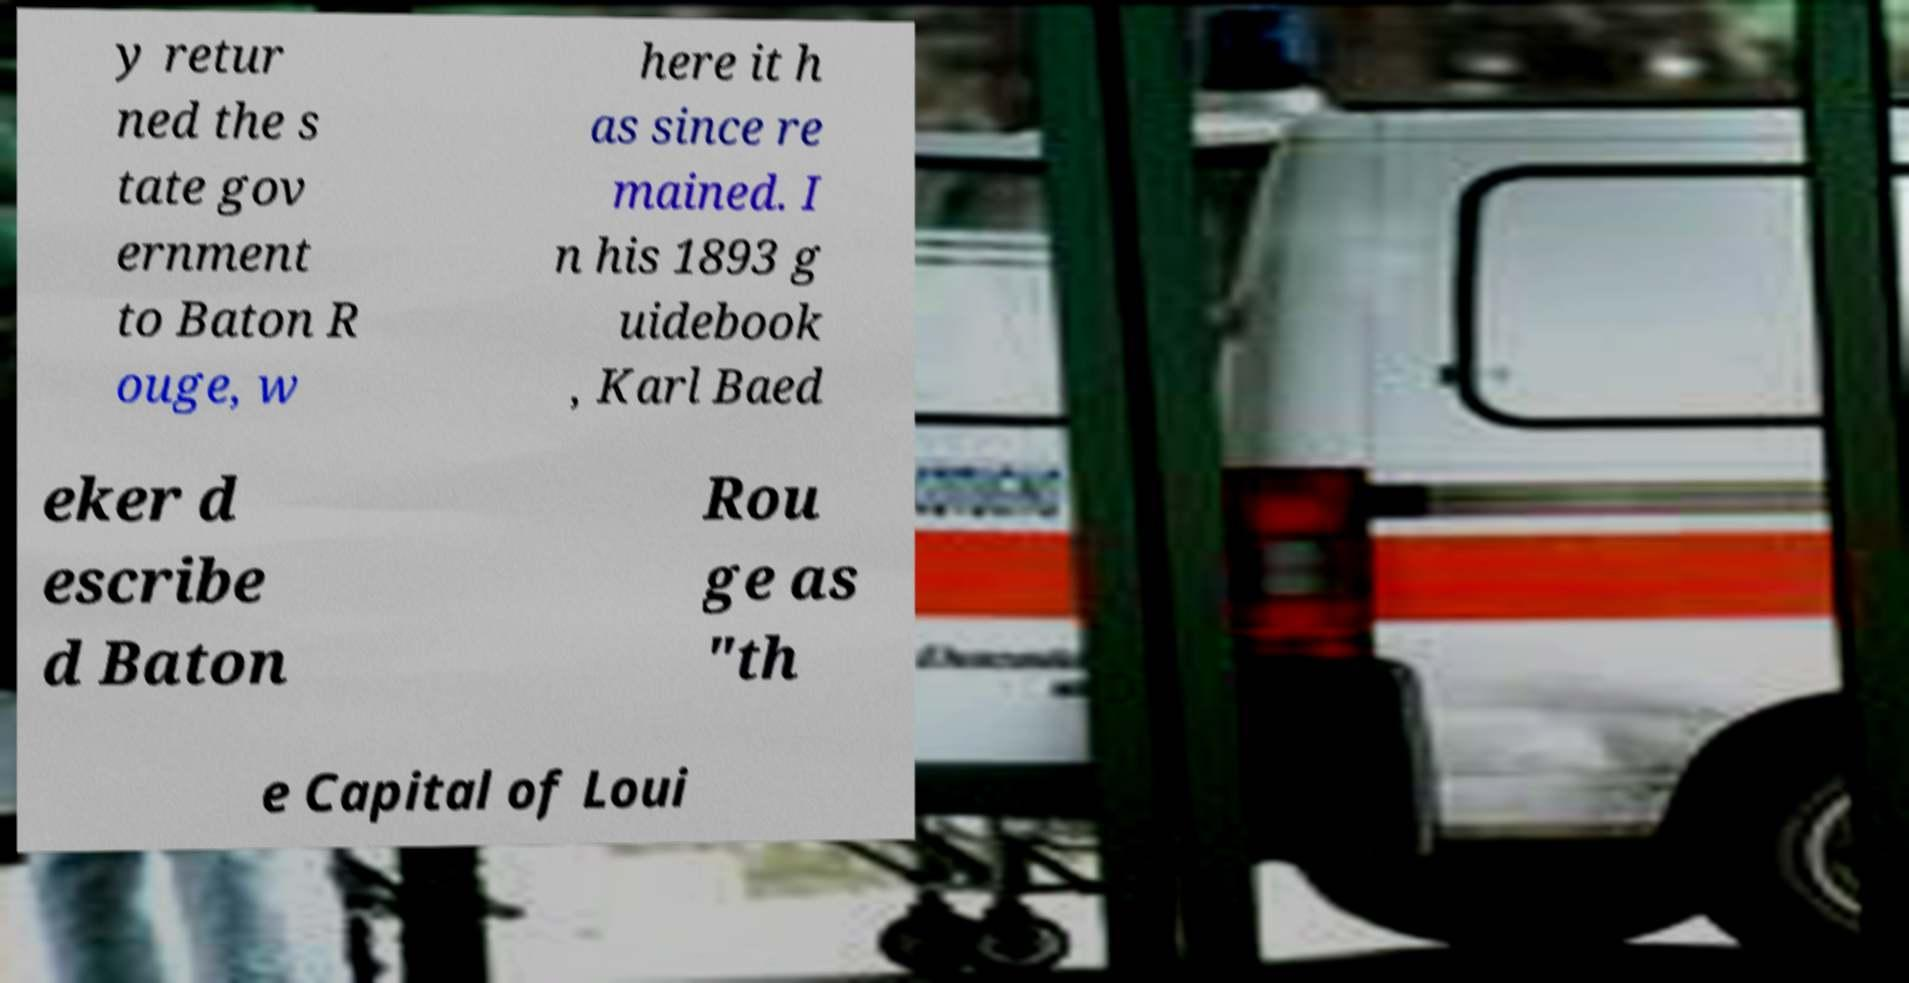Please identify and transcribe the text found in this image. y retur ned the s tate gov ernment to Baton R ouge, w here it h as since re mained. I n his 1893 g uidebook , Karl Baed eker d escribe d Baton Rou ge as "th e Capital of Loui 